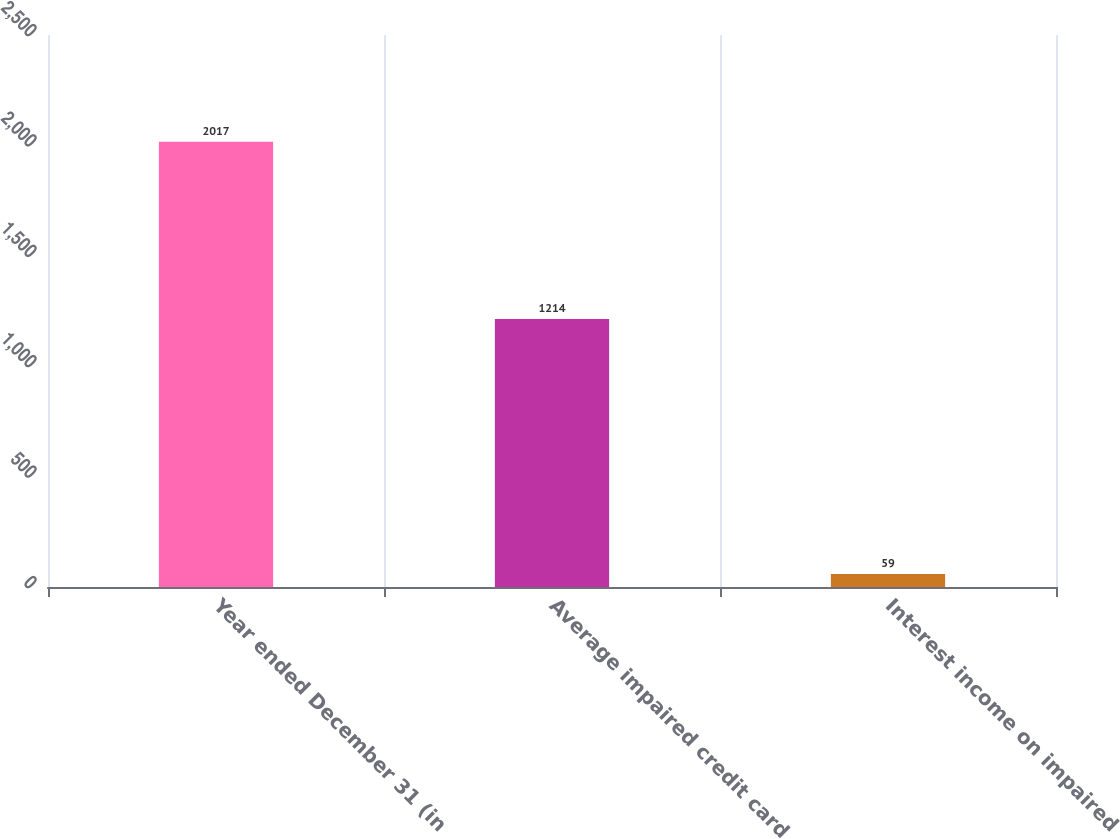<chart> <loc_0><loc_0><loc_500><loc_500><bar_chart><fcel>Year ended December 31 (in<fcel>Average impaired credit card<fcel>Interest income on impaired<nl><fcel>2017<fcel>1214<fcel>59<nl></chart> 